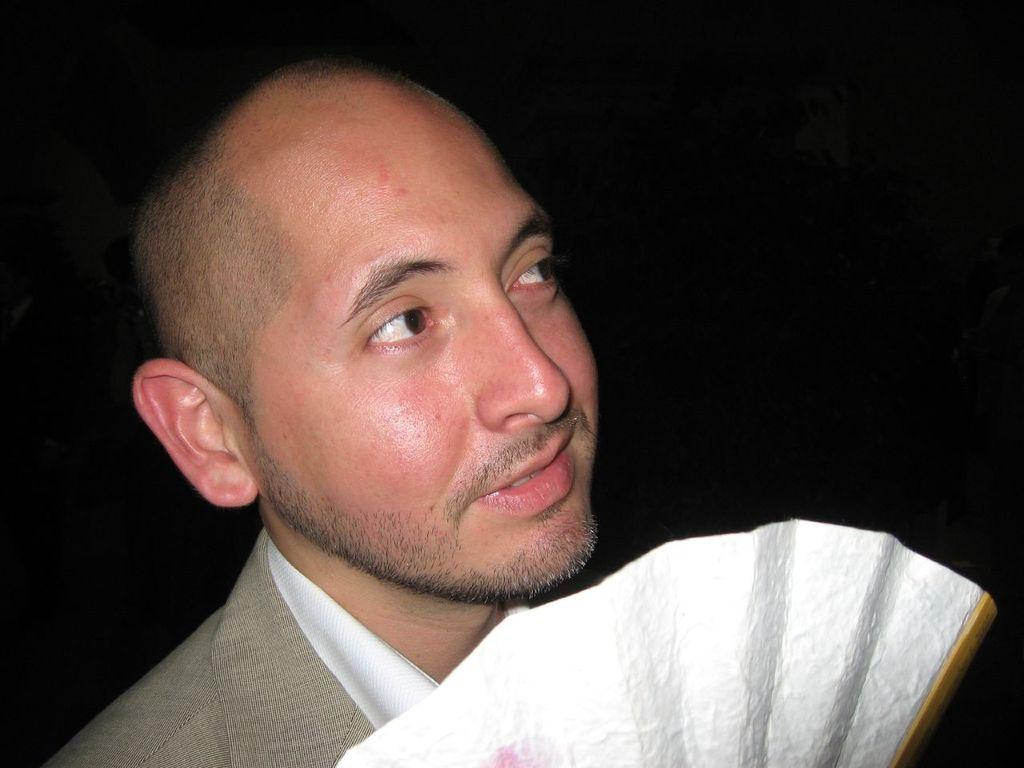What is the main subject of the image? There is a person in the image. What is the person's facial expression? The person is smiling. What is the person holding in their hand? The person is holding something in their hand, but the specific object is not mentioned in the facts. How would you describe the background of the image? The background of the image is dark. What type of sail can be seen in the image? There is no sail present in the image. Is the person embarking on a voyage in the image? The facts provided do not mention any voyage or travel-related activity. 